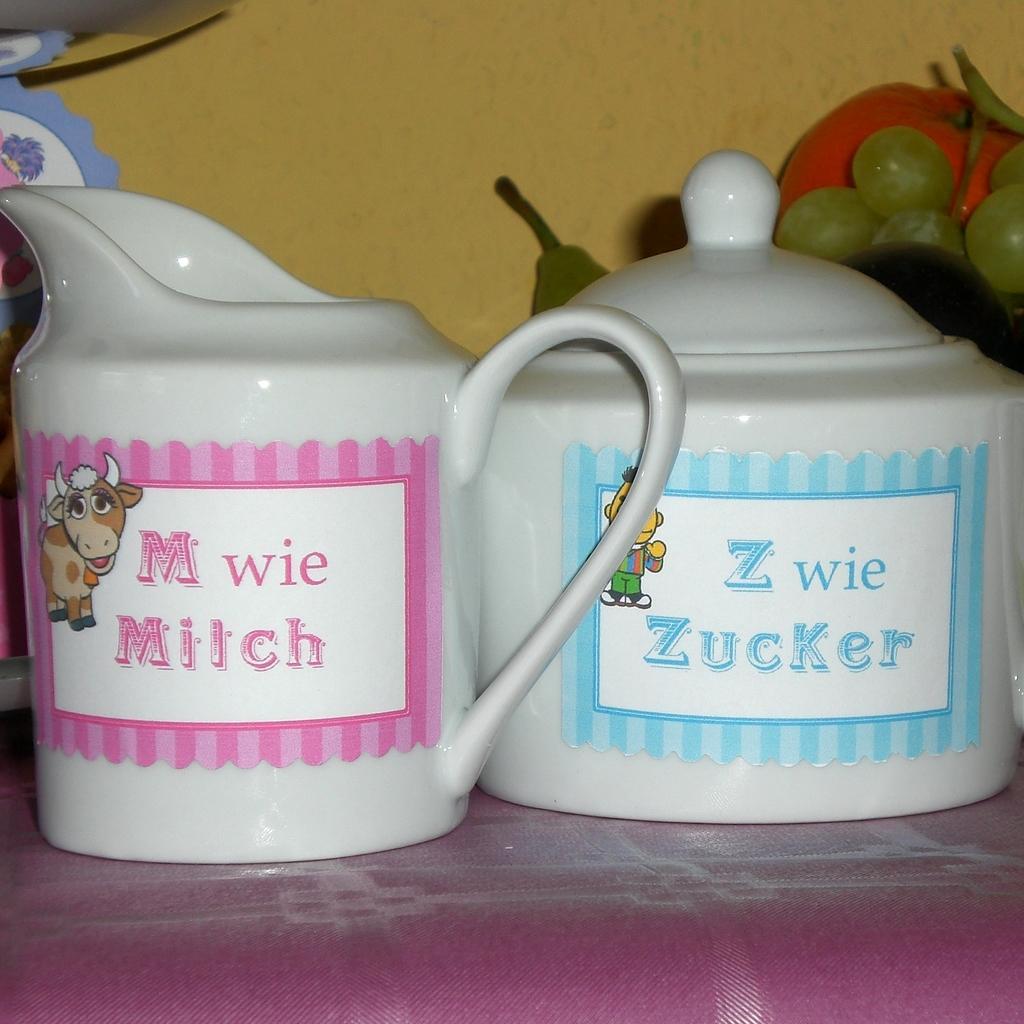Can you describe this image briefly? There are two glass vessels and behind the second vessel there are some fruits. 